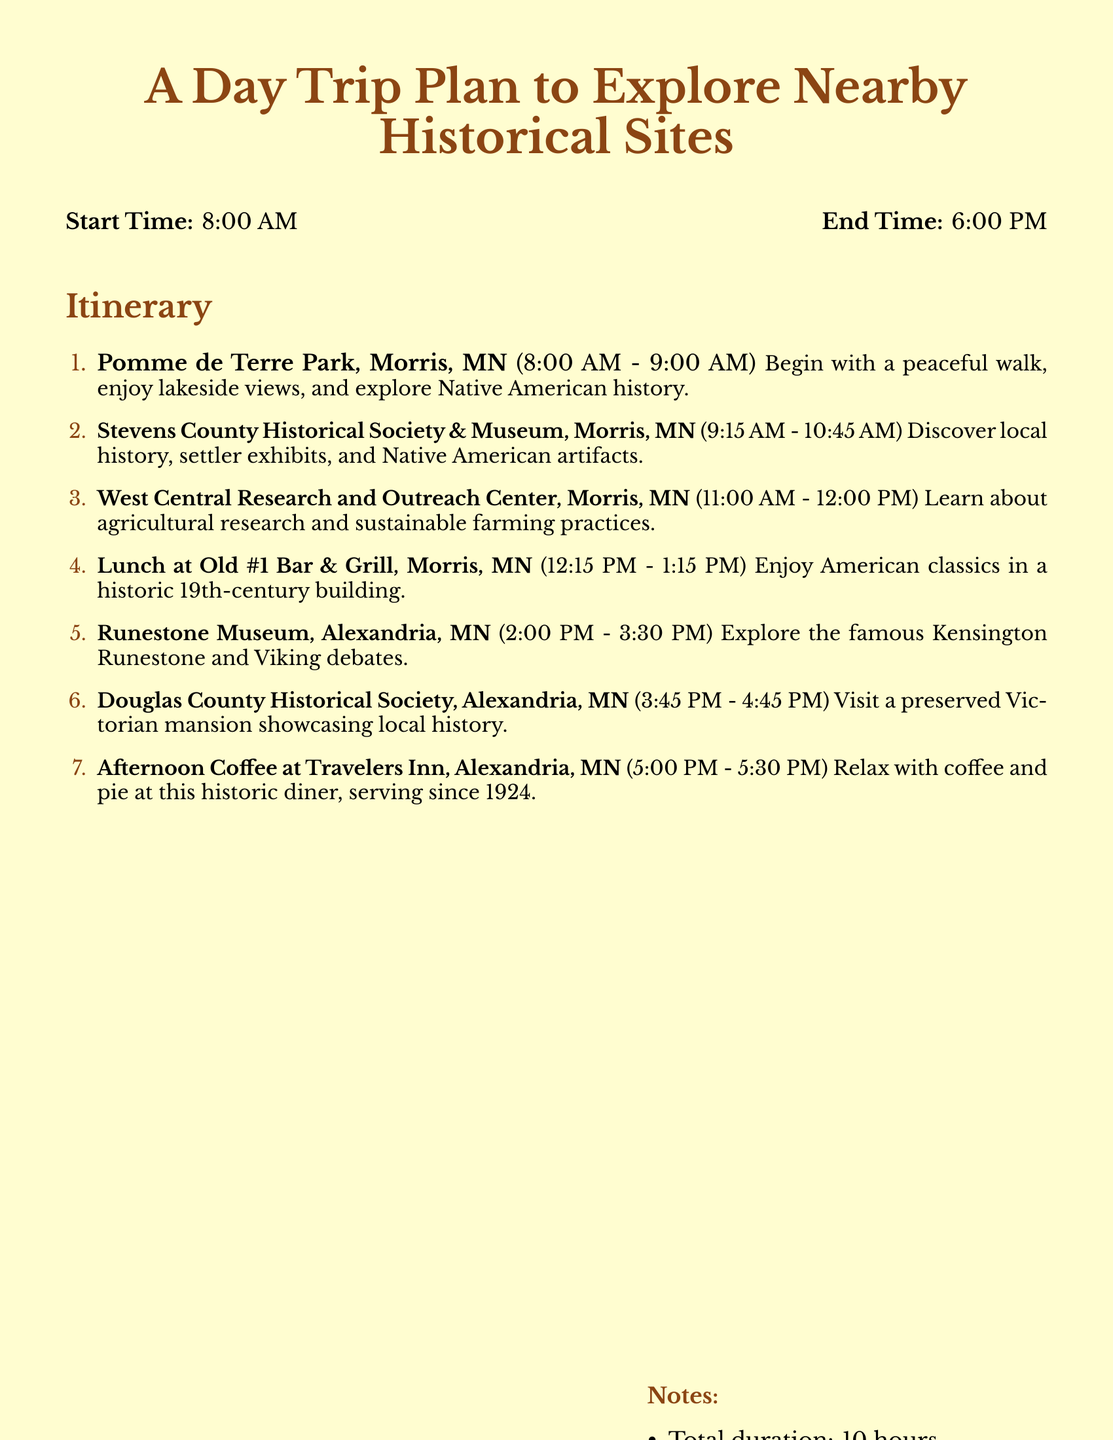What is the start time of the trip? The start time of the trip is given at the beginning of the itinerary.
Answer: 8:00 AM What is the end time of the trip? The end time of the trip is mentioned alongside the start time.
Answer: 6:00 PM How long is the visit at the Stevens County Historical Society & Museum? The duration of the visit is specified next to the location in the itinerary.
Answer: 1 hour 30 minutes Which restaurant is listed for lunch? The itinerary states the name of the restaurant where lunch will take place.
Answer: Old #1 Bar & Grill What historical artifact is explored at the Runestone Museum? The museum's description mentions a specific artifact discussed during the visit.
Answer: Kensington Runestone How many total stops are included in the itinerary? The number of items listed in the itinerary indicates the total stops.
Answer: 7 What should participants bring for the trip? Notes at the end of the itinerary suggest necessary items for the participants.
Answer: Comfortable walking shoes At what time is the afternoon coffee scheduled? The itinerary clearly specifies the time set for the afternoon coffee break.
Answer: 5:00 PM What is the total duration of the trip? The total duration is specified in the notes section of the itinerary.
Answer: 10 hours 